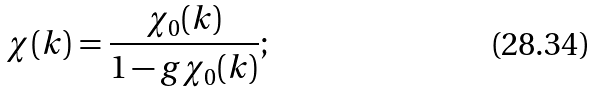<formula> <loc_0><loc_0><loc_500><loc_500>\chi ( k ) = \frac { \chi _ { 0 } ( k ) } { 1 - g \chi _ { 0 } ( k ) } ;</formula> 